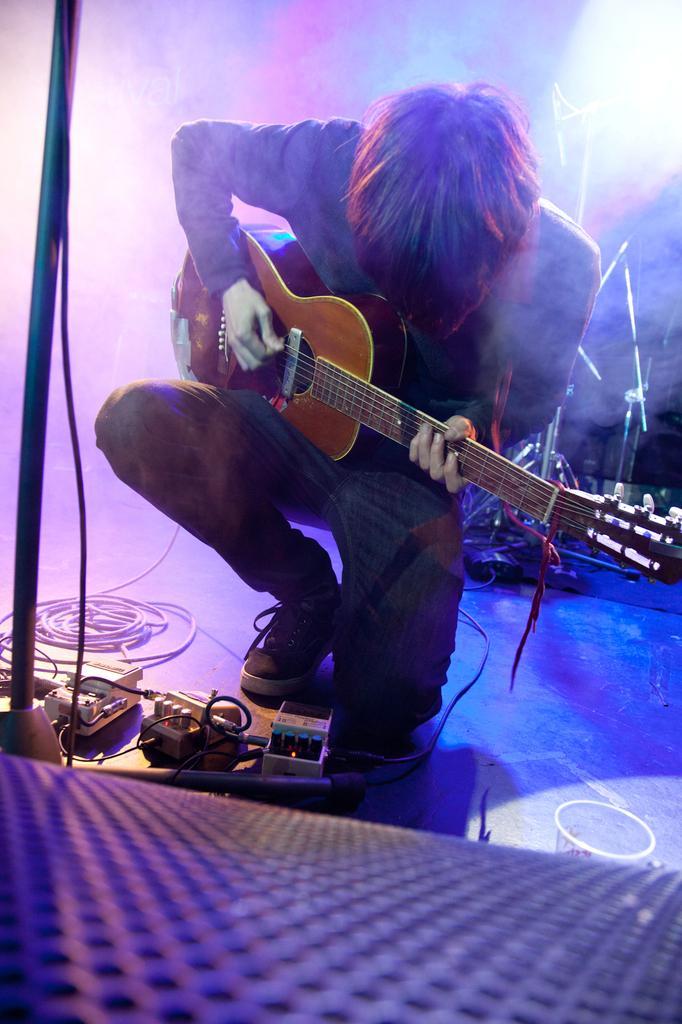How would you summarize this image in a sentence or two? This picture is taken in musical concert. Here, in this picture, the man in blue shirt and blue jeans is carrying guitar in his hands and he is playing it. In front of him, we see many cables and wires and also a microphone stand. 